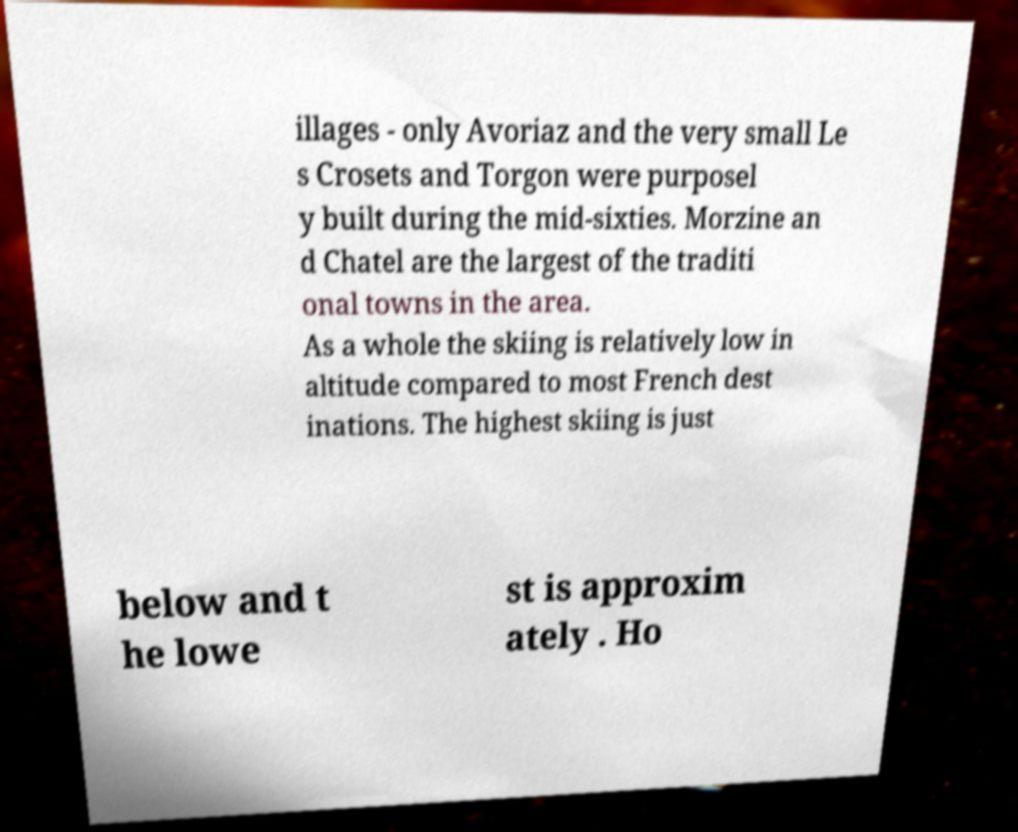What messages or text are displayed in this image? I need them in a readable, typed format. illages - only Avoriaz and the very small Le s Crosets and Torgon were purposel y built during the mid-sixties. Morzine an d Chatel are the largest of the traditi onal towns in the area. As a whole the skiing is relatively low in altitude compared to most French dest inations. The highest skiing is just below and t he lowe st is approxim ately . Ho 